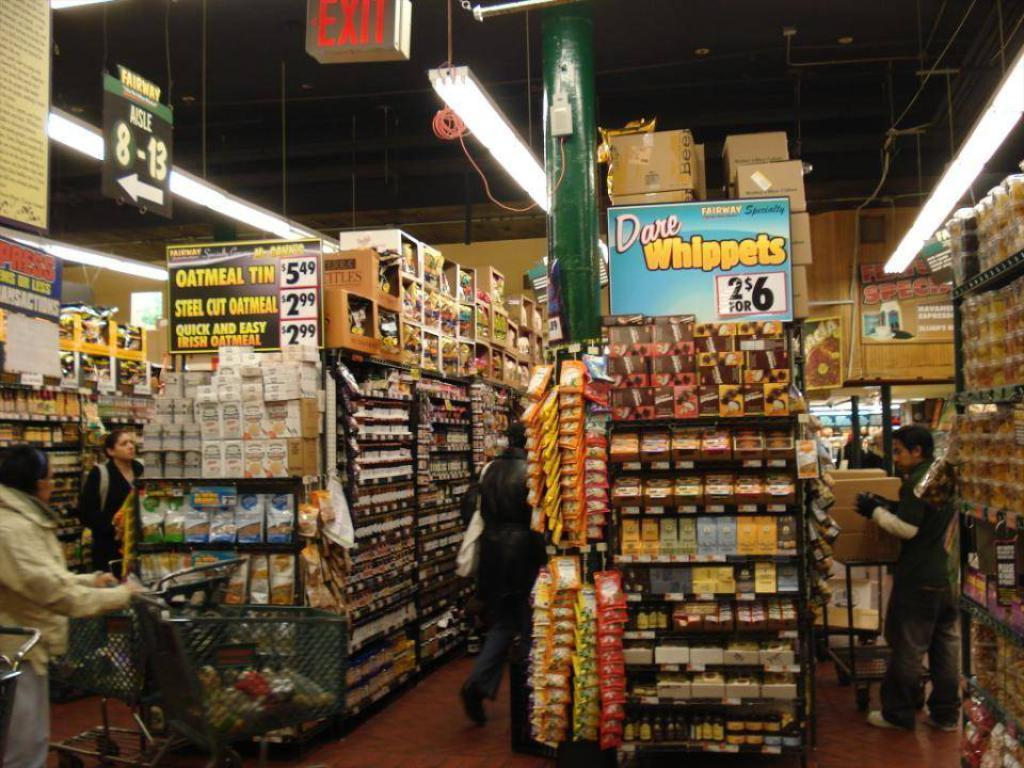<image>
Write a terse but informative summary of the picture. an inside view of store shelves with ads for Dare Whippets 